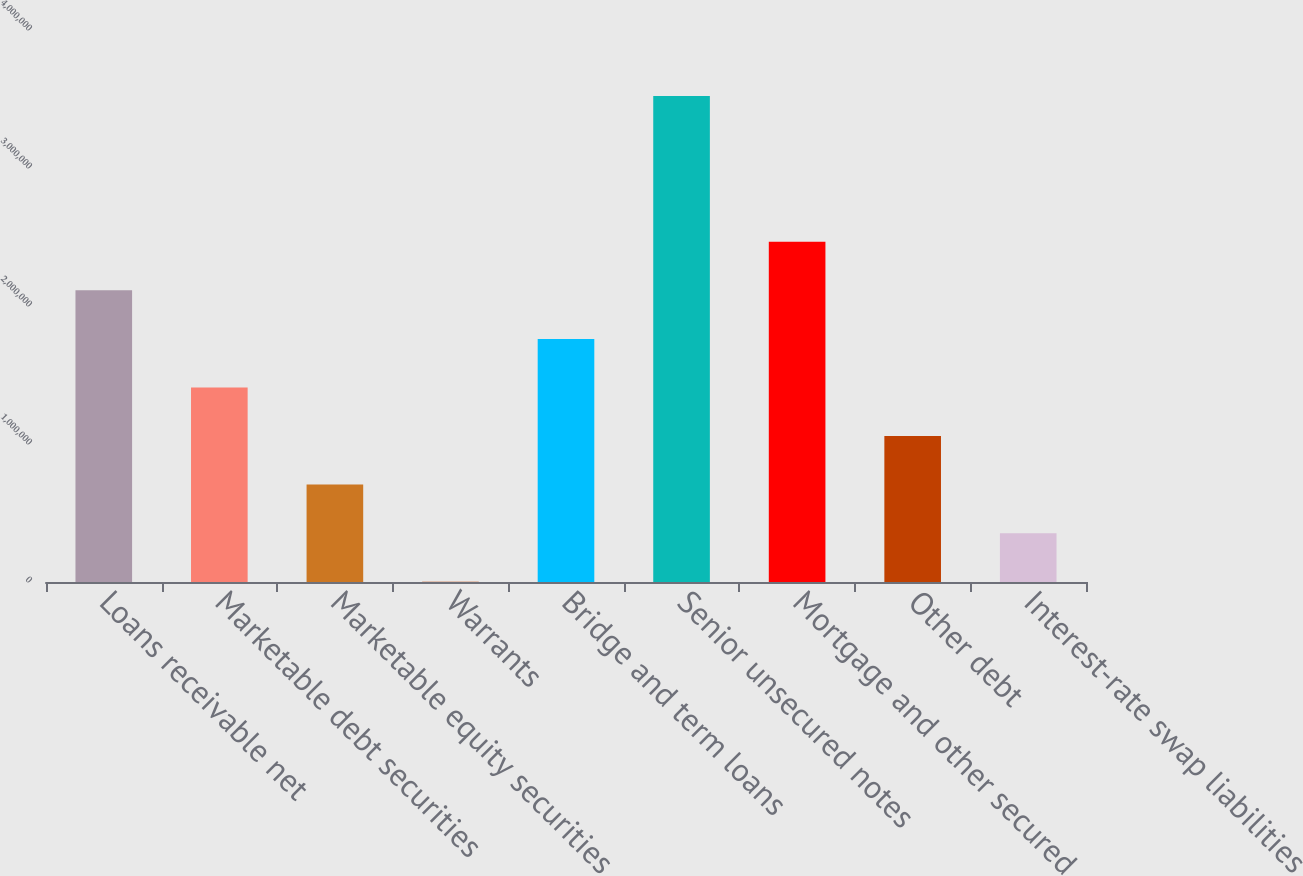Convert chart to OTSL. <chart><loc_0><loc_0><loc_500><loc_500><bar_chart><fcel>Loans receivable net<fcel>Marketable debt securities<fcel>Marketable equity securities<fcel>Warrants<fcel>Bridge and term loans<fcel>Senior unsecured notes<fcel>Mortgage and other secured<fcel>Other debt<fcel>Interest-rate swap liabilities<nl><fcel>2.11349e+06<fcel>1.40957e+06<fcel>705651<fcel>1732<fcel>1.76153e+06<fcel>3.52132e+06<fcel>2.46545e+06<fcel>1.05761e+06<fcel>353691<nl></chart> 